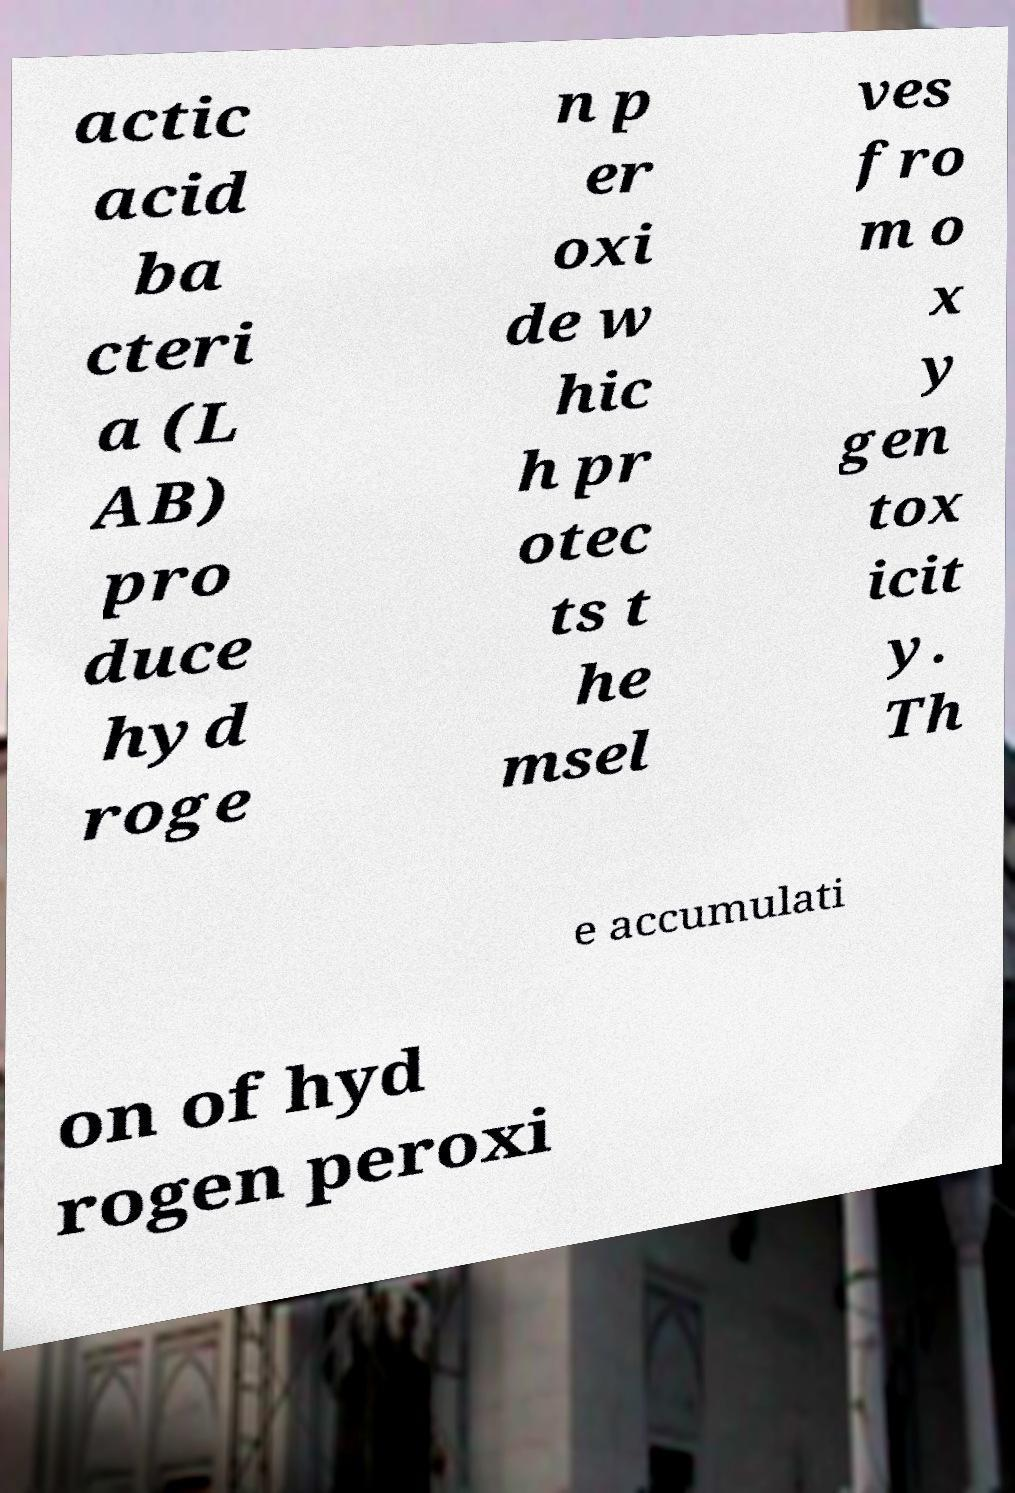For documentation purposes, I need the text within this image transcribed. Could you provide that? actic acid ba cteri a (L AB) pro duce hyd roge n p er oxi de w hic h pr otec ts t he msel ves fro m o x y gen tox icit y. Th e accumulati on of hyd rogen peroxi 